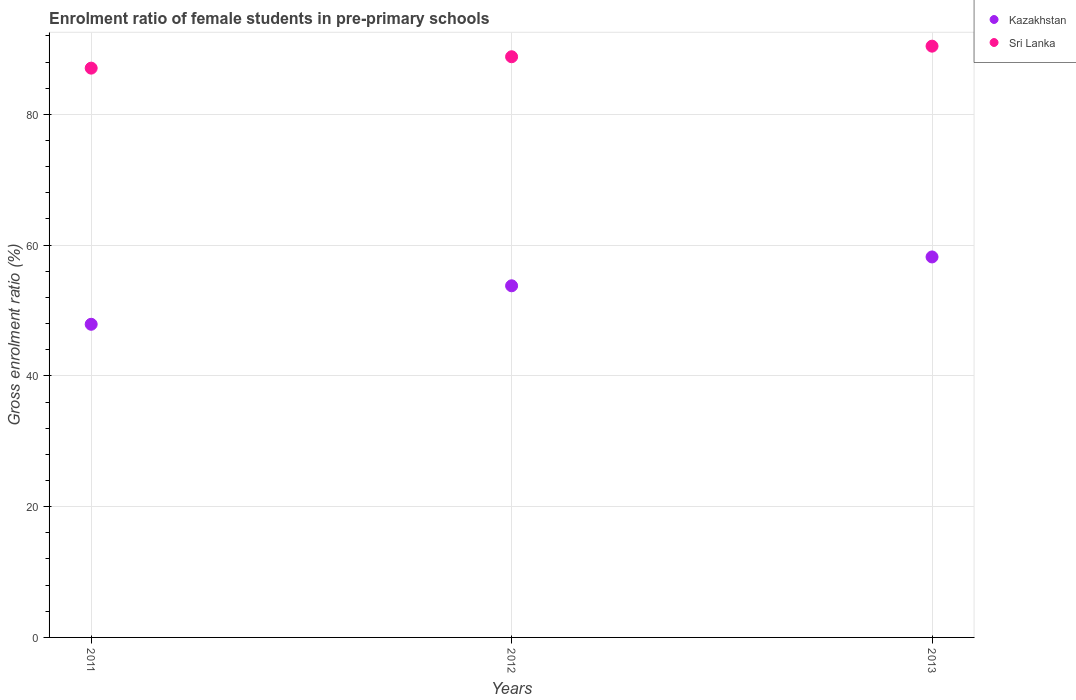Is the number of dotlines equal to the number of legend labels?
Your response must be concise. Yes. What is the enrolment ratio of female students in pre-primary schools in Kazakhstan in 2011?
Offer a terse response. 47.89. Across all years, what is the maximum enrolment ratio of female students in pre-primary schools in Kazakhstan?
Provide a succinct answer. 58.19. Across all years, what is the minimum enrolment ratio of female students in pre-primary schools in Sri Lanka?
Your answer should be very brief. 87.07. What is the total enrolment ratio of female students in pre-primary schools in Sri Lanka in the graph?
Keep it short and to the point. 266.31. What is the difference between the enrolment ratio of female students in pre-primary schools in Kazakhstan in 2011 and that in 2013?
Your answer should be compact. -10.3. What is the difference between the enrolment ratio of female students in pre-primary schools in Kazakhstan in 2011 and the enrolment ratio of female students in pre-primary schools in Sri Lanka in 2013?
Give a very brief answer. -42.54. What is the average enrolment ratio of female students in pre-primary schools in Kazakhstan per year?
Your answer should be very brief. 53.29. In the year 2012, what is the difference between the enrolment ratio of female students in pre-primary schools in Sri Lanka and enrolment ratio of female students in pre-primary schools in Kazakhstan?
Provide a short and direct response. 35.03. What is the ratio of the enrolment ratio of female students in pre-primary schools in Kazakhstan in 2011 to that in 2013?
Provide a short and direct response. 0.82. Is the difference between the enrolment ratio of female students in pre-primary schools in Sri Lanka in 2012 and 2013 greater than the difference between the enrolment ratio of female students in pre-primary schools in Kazakhstan in 2012 and 2013?
Provide a short and direct response. Yes. What is the difference between the highest and the second highest enrolment ratio of female students in pre-primary schools in Sri Lanka?
Your answer should be very brief. 1.62. What is the difference between the highest and the lowest enrolment ratio of female students in pre-primary schools in Kazakhstan?
Ensure brevity in your answer.  10.3. Does the enrolment ratio of female students in pre-primary schools in Sri Lanka monotonically increase over the years?
Make the answer very short. Yes. How many dotlines are there?
Provide a short and direct response. 2. What is the difference between two consecutive major ticks on the Y-axis?
Your answer should be very brief. 20. Are the values on the major ticks of Y-axis written in scientific E-notation?
Ensure brevity in your answer.  No. Does the graph contain any zero values?
Your response must be concise. No. Does the graph contain grids?
Your answer should be compact. Yes. How many legend labels are there?
Your answer should be very brief. 2. What is the title of the graph?
Offer a terse response. Enrolment ratio of female students in pre-primary schools. What is the Gross enrolment ratio (%) in Kazakhstan in 2011?
Offer a terse response. 47.89. What is the Gross enrolment ratio (%) in Sri Lanka in 2011?
Provide a short and direct response. 87.07. What is the Gross enrolment ratio (%) of Kazakhstan in 2012?
Keep it short and to the point. 53.78. What is the Gross enrolment ratio (%) of Sri Lanka in 2012?
Provide a succinct answer. 88.81. What is the Gross enrolment ratio (%) of Kazakhstan in 2013?
Offer a terse response. 58.19. What is the Gross enrolment ratio (%) in Sri Lanka in 2013?
Your response must be concise. 90.43. Across all years, what is the maximum Gross enrolment ratio (%) in Kazakhstan?
Offer a very short reply. 58.19. Across all years, what is the maximum Gross enrolment ratio (%) of Sri Lanka?
Keep it short and to the point. 90.43. Across all years, what is the minimum Gross enrolment ratio (%) of Kazakhstan?
Provide a succinct answer. 47.89. Across all years, what is the minimum Gross enrolment ratio (%) in Sri Lanka?
Keep it short and to the point. 87.07. What is the total Gross enrolment ratio (%) of Kazakhstan in the graph?
Keep it short and to the point. 159.86. What is the total Gross enrolment ratio (%) in Sri Lanka in the graph?
Provide a short and direct response. 266.31. What is the difference between the Gross enrolment ratio (%) in Kazakhstan in 2011 and that in 2012?
Your response must be concise. -5.89. What is the difference between the Gross enrolment ratio (%) in Sri Lanka in 2011 and that in 2012?
Provide a short and direct response. -1.74. What is the difference between the Gross enrolment ratio (%) in Kazakhstan in 2011 and that in 2013?
Provide a succinct answer. -10.3. What is the difference between the Gross enrolment ratio (%) in Sri Lanka in 2011 and that in 2013?
Offer a very short reply. -3.36. What is the difference between the Gross enrolment ratio (%) in Kazakhstan in 2012 and that in 2013?
Ensure brevity in your answer.  -4.41. What is the difference between the Gross enrolment ratio (%) of Sri Lanka in 2012 and that in 2013?
Offer a very short reply. -1.62. What is the difference between the Gross enrolment ratio (%) in Kazakhstan in 2011 and the Gross enrolment ratio (%) in Sri Lanka in 2012?
Offer a very short reply. -40.92. What is the difference between the Gross enrolment ratio (%) of Kazakhstan in 2011 and the Gross enrolment ratio (%) of Sri Lanka in 2013?
Your answer should be compact. -42.54. What is the difference between the Gross enrolment ratio (%) of Kazakhstan in 2012 and the Gross enrolment ratio (%) of Sri Lanka in 2013?
Offer a very short reply. -36.65. What is the average Gross enrolment ratio (%) of Kazakhstan per year?
Make the answer very short. 53.29. What is the average Gross enrolment ratio (%) of Sri Lanka per year?
Provide a succinct answer. 88.77. In the year 2011, what is the difference between the Gross enrolment ratio (%) in Kazakhstan and Gross enrolment ratio (%) in Sri Lanka?
Provide a short and direct response. -39.18. In the year 2012, what is the difference between the Gross enrolment ratio (%) of Kazakhstan and Gross enrolment ratio (%) of Sri Lanka?
Offer a very short reply. -35.03. In the year 2013, what is the difference between the Gross enrolment ratio (%) in Kazakhstan and Gross enrolment ratio (%) in Sri Lanka?
Give a very brief answer. -32.24. What is the ratio of the Gross enrolment ratio (%) of Kazakhstan in 2011 to that in 2012?
Ensure brevity in your answer.  0.89. What is the ratio of the Gross enrolment ratio (%) of Sri Lanka in 2011 to that in 2012?
Offer a very short reply. 0.98. What is the ratio of the Gross enrolment ratio (%) of Kazakhstan in 2011 to that in 2013?
Your answer should be compact. 0.82. What is the ratio of the Gross enrolment ratio (%) in Sri Lanka in 2011 to that in 2013?
Your response must be concise. 0.96. What is the ratio of the Gross enrolment ratio (%) of Kazakhstan in 2012 to that in 2013?
Offer a terse response. 0.92. What is the ratio of the Gross enrolment ratio (%) of Sri Lanka in 2012 to that in 2013?
Provide a short and direct response. 0.98. What is the difference between the highest and the second highest Gross enrolment ratio (%) in Kazakhstan?
Your answer should be compact. 4.41. What is the difference between the highest and the second highest Gross enrolment ratio (%) in Sri Lanka?
Your response must be concise. 1.62. What is the difference between the highest and the lowest Gross enrolment ratio (%) in Kazakhstan?
Ensure brevity in your answer.  10.3. What is the difference between the highest and the lowest Gross enrolment ratio (%) in Sri Lanka?
Your answer should be very brief. 3.36. 